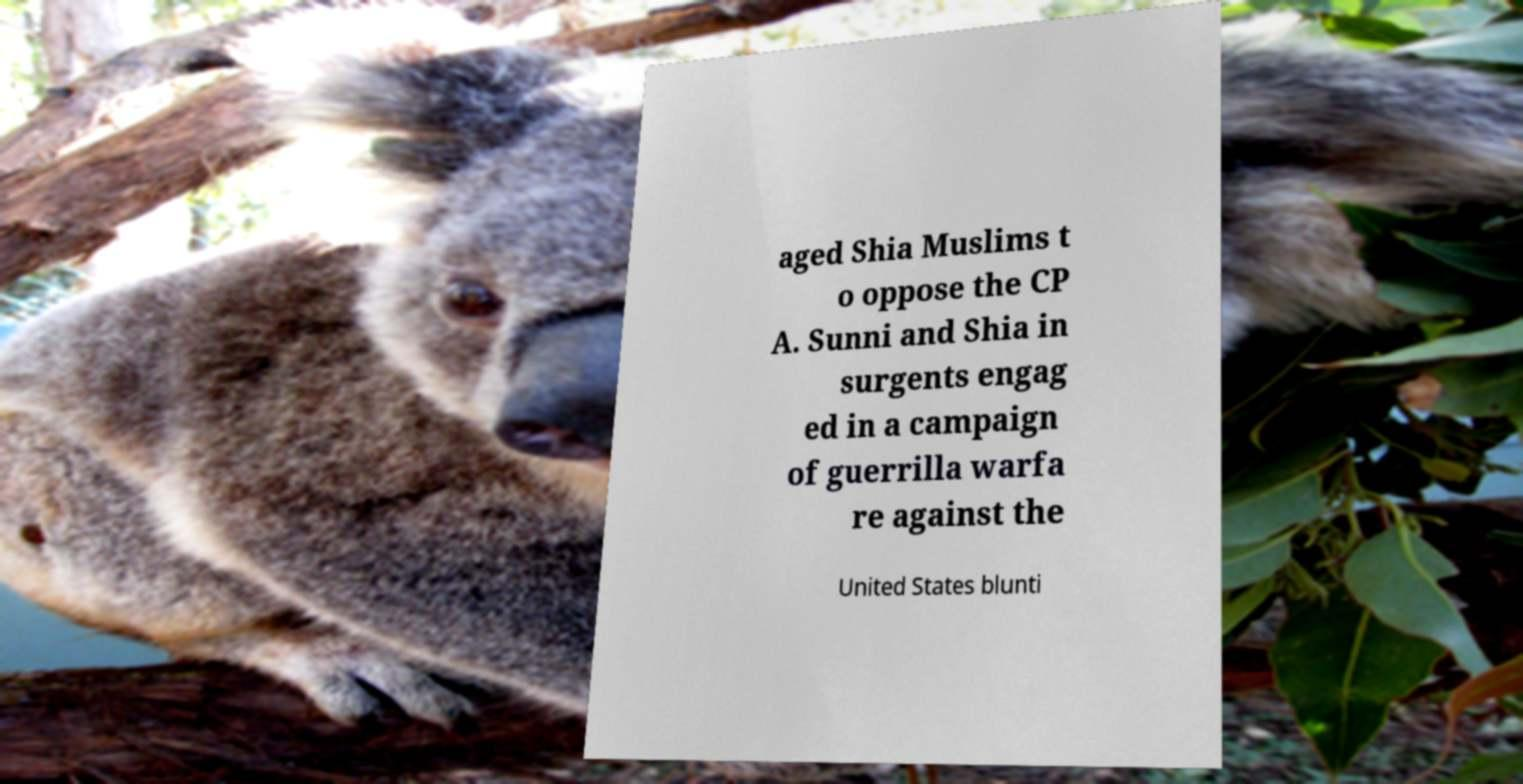For documentation purposes, I need the text within this image transcribed. Could you provide that? aged Shia Muslims t o oppose the CP A. Sunni and Shia in surgents engag ed in a campaign of guerrilla warfa re against the United States blunti 